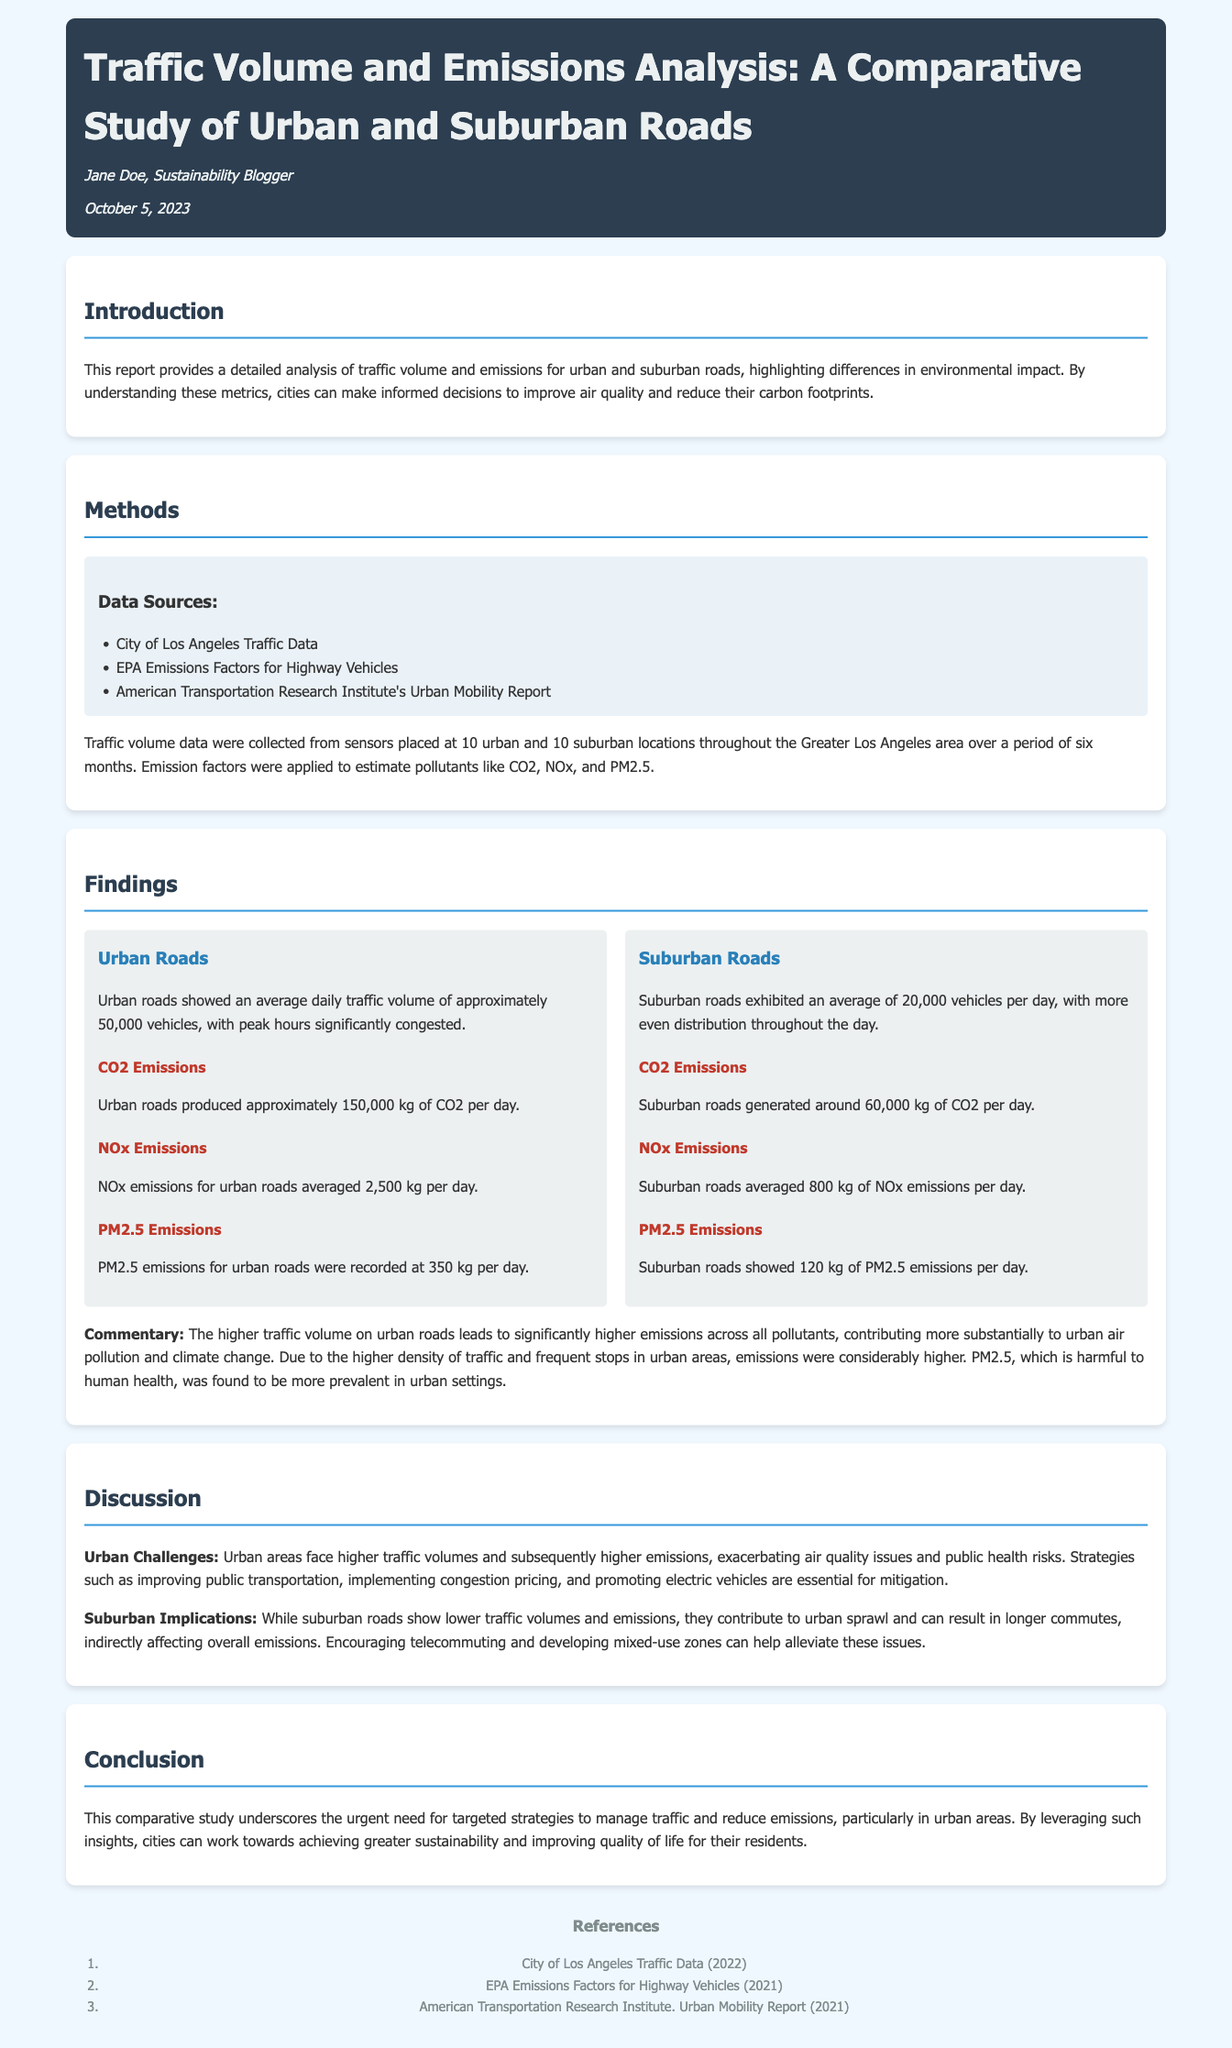what is the average daily traffic volume on urban roads? The report states that urban roads showed an average daily traffic volume of approximately 50,000 vehicles.
Answer: 50,000 vehicles what are the CO2 emissions from suburban roads? CO2 emissions for suburban roads are reported to be around 60,000 kg per day.
Answer: 60,000 kg who authored the report? The report is authored by Jane Doe, who is identified as a sustainability blogger.
Answer: Jane Doe what is the primary focus of the discussion section? The discussion emphasizes the challenges and implications of urban and suburban traffic volumes and emissions.
Answer: Challenges and implications how many suburban locations were analyzed in the study? The study analyzed data from 10 suburban locations throughout the Greater Los Angeles area.
Answer: 10 suburban locations what pollutant had the highest emissions in urban areas? The report indicates that CO2 emissions were the highest among pollutants in urban roads, at approximately 150,000 kg per day.
Answer: CO2 how do suburban roads contribute to emissions indirectly? The discussion notes that suburban roads can lead to urban sprawl and longer commutes, indirectly affecting overall emissions.
Answer: Urban sprawl and longer commutes what date was the report published? The date of publication, as stated in the document, is October 5, 2023.
Answer: October 5, 2023 what is one recommended strategy for urban areas to mitigate emissions? The report suggests implementing congestion pricing as a strategy to mitigate emissions in urban areas.
Answer: Implementing congestion pricing 